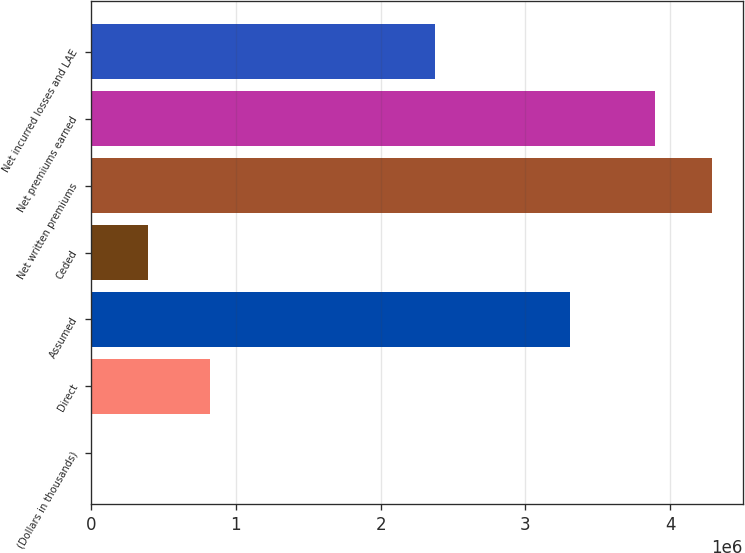Convert chart to OTSL. <chart><loc_0><loc_0><loc_500><loc_500><bar_chart><fcel>(Dollars in thousands)<fcel>Direct<fcel>Assumed<fcel>Ceded<fcel>Net written premiums<fcel>Net premiums earned<fcel>Net incurred losses and LAE<nl><fcel>2009<fcel>824366<fcel>3.30459e+06<fcel>394784<fcel>4.28687e+06<fcel>3.8941e+06<fcel>2.37406e+06<nl></chart> 